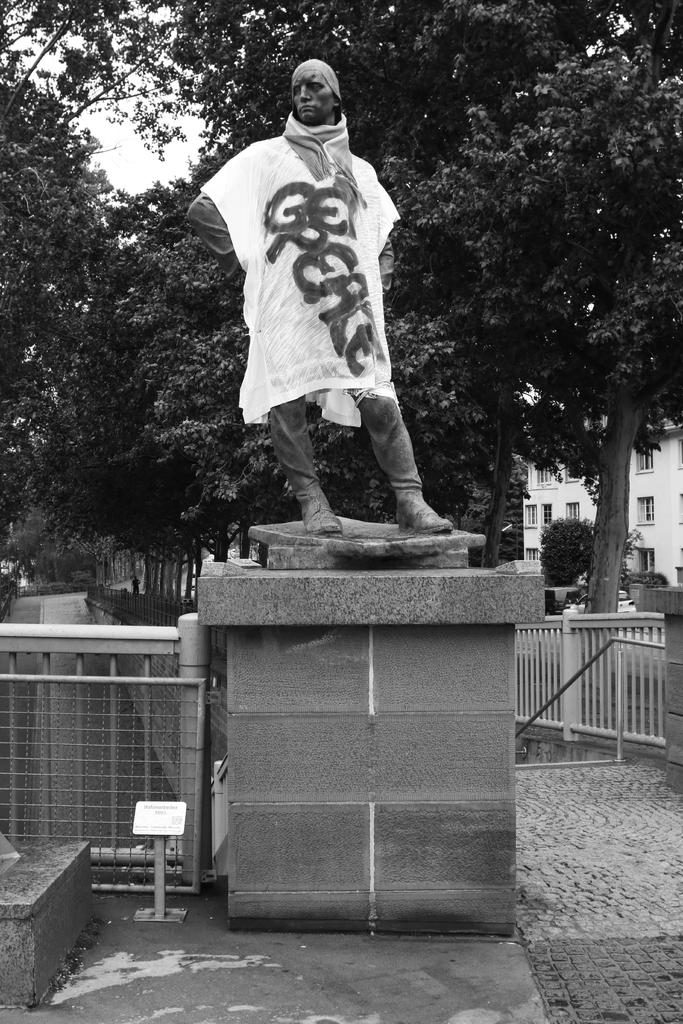What object is present in the image that resembles a staff with a decorative top? There is a scepter in the image. What type of natural vegetation can be seen in the image? There are trees in the image. What type of man-made structures are visible in the image? There are buildings in the image. What type of lock can be seen on the scepter in the image? There is no lock present on the scepter in the image. What material is the box made of that is visible in the image? There is no box present in the image. 